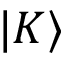Convert formula to latex. <formula><loc_0><loc_0><loc_500><loc_500>{ | K \rangle }</formula> 